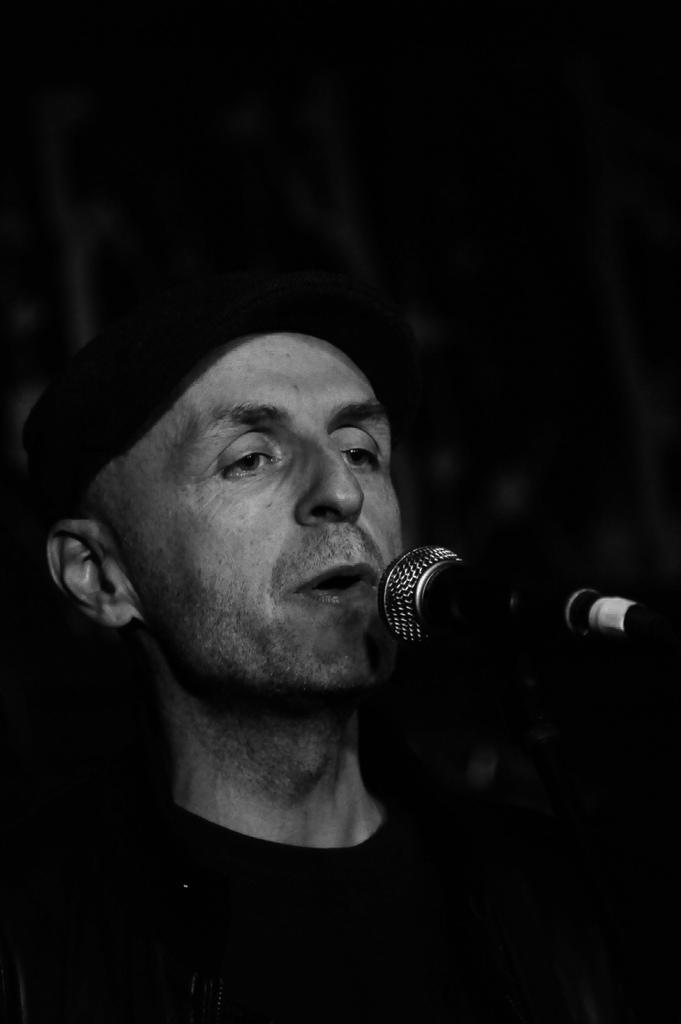What is the main subject of the image? There is a person in the image. What is the person doing in the image? The person is singing. What object is the person using while singing? The person is in front of a microphone. What color scheme is used in the image? The image is in black and white. What type of lock can be seen on the person's head in the image? There is no lock present on the person's head in the image. What idea does the caption of the image convey? There is no caption present in the image, so it's not possible to determine what idea the caption might convey. 